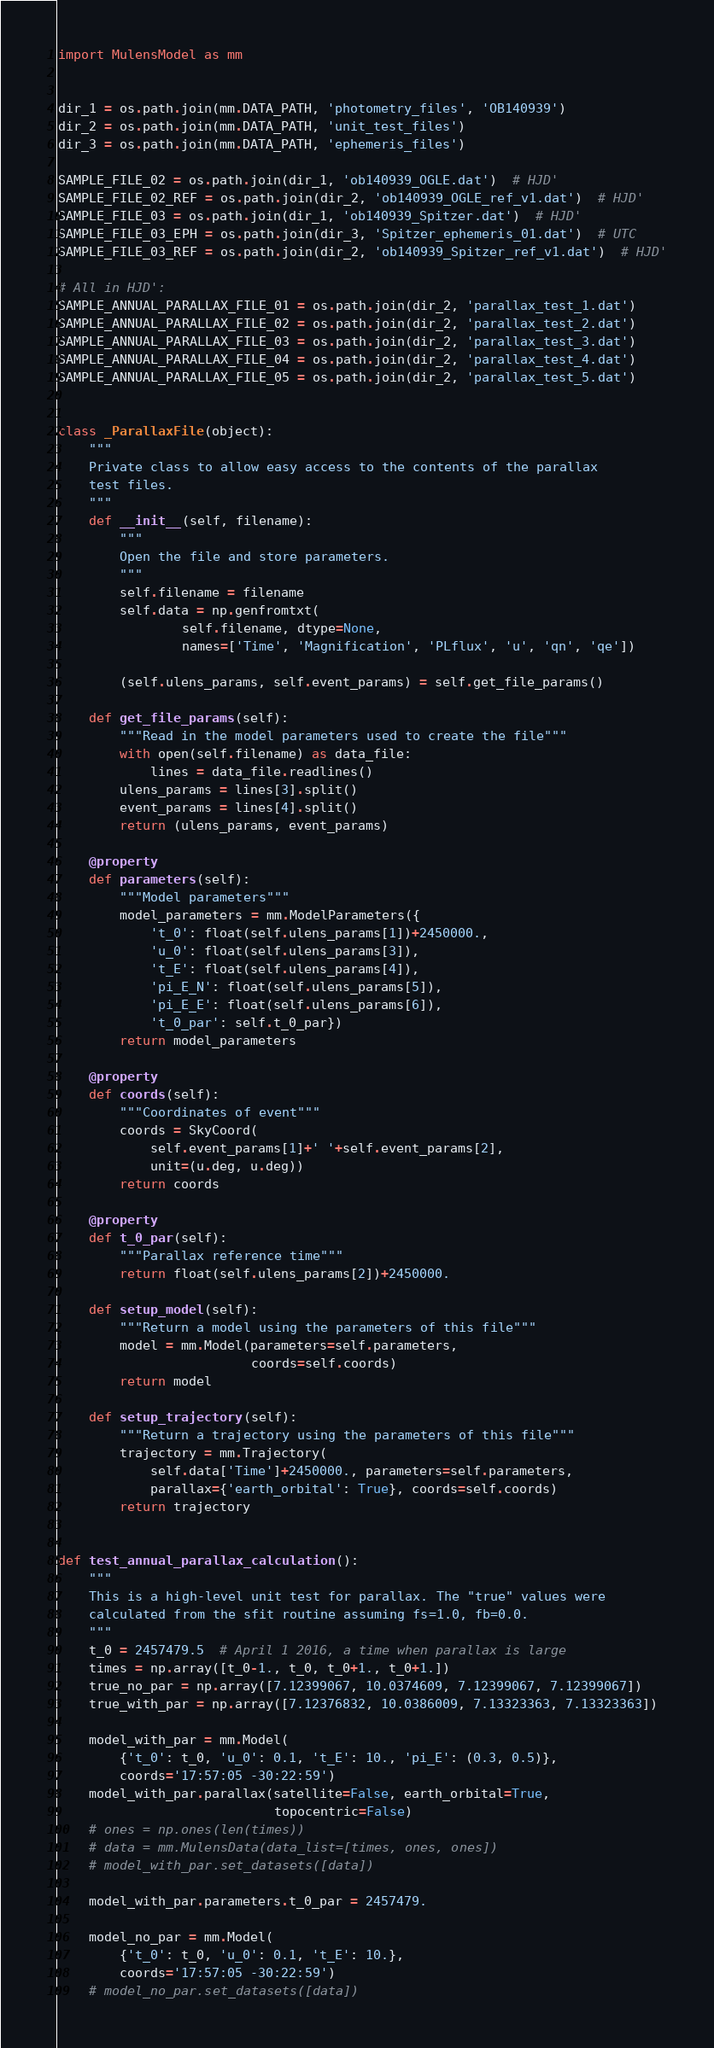Convert code to text. <code><loc_0><loc_0><loc_500><loc_500><_Python_>
import MulensModel as mm


dir_1 = os.path.join(mm.DATA_PATH, 'photometry_files', 'OB140939')
dir_2 = os.path.join(mm.DATA_PATH, 'unit_test_files')
dir_3 = os.path.join(mm.DATA_PATH, 'ephemeris_files')

SAMPLE_FILE_02 = os.path.join(dir_1, 'ob140939_OGLE.dat')  # HJD'
SAMPLE_FILE_02_REF = os.path.join(dir_2, 'ob140939_OGLE_ref_v1.dat')  # HJD'
SAMPLE_FILE_03 = os.path.join(dir_1, 'ob140939_Spitzer.dat')  # HJD'
SAMPLE_FILE_03_EPH = os.path.join(dir_3, 'Spitzer_ephemeris_01.dat')  # UTC
SAMPLE_FILE_03_REF = os.path.join(dir_2, 'ob140939_Spitzer_ref_v1.dat')  # HJD'

# All in HJD':
SAMPLE_ANNUAL_PARALLAX_FILE_01 = os.path.join(dir_2, 'parallax_test_1.dat')
SAMPLE_ANNUAL_PARALLAX_FILE_02 = os.path.join(dir_2, 'parallax_test_2.dat')
SAMPLE_ANNUAL_PARALLAX_FILE_03 = os.path.join(dir_2, 'parallax_test_3.dat')
SAMPLE_ANNUAL_PARALLAX_FILE_04 = os.path.join(dir_2, 'parallax_test_4.dat')
SAMPLE_ANNUAL_PARALLAX_FILE_05 = os.path.join(dir_2, 'parallax_test_5.dat')


class _ParallaxFile(object):
    """
    Private class to allow easy access to the contents of the parallax
    test files.
    """
    def __init__(self, filename):
        """
        Open the file and store parameters.
        """
        self.filename = filename
        self.data = np.genfromtxt(
                self.filename, dtype=None,
                names=['Time', 'Magnification', 'PLflux', 'u', 'qn', 'qe'])

        (self.ulens_params, self.event_params) = self.get_file_params()

    def get_file_params(self):
        """Read in the model parameters used to create the file"""
        with open(self.filename) as data_file:
            lines = data_file.readlines()
        ulens_params = lines[3].split()
        event_params = lines[4].split()
        return (ulens_params, event_params)

    @property
    def parameters(self):
        """Model parameters"""
        model_parameters = mm.ModelParameters({
            't_0': float(self.ulens_params[1])+2450000.,
            'u_0': float(self.ulens_params[3]),
            't_E': float(self.ulens_params[4]),
            'pi_E_N': float(self.ulens_params[5]),
            'pi_E_E': float(self.ulens_params[6]),
            't_0_par': self.t_0_par})
        return model_parameters

    @property
    def coords(self):
        """Coordinates of event"""
        coords = SkyCoord(
            self.event_params[1]+' '+self.event_params[2],
            unit=(u.deg, u.deg))
        return coords

    @property
    def t_0_par(self):
        """Parallax reference time"""
        return float(self.ulens_params[2])+2450000.

    def setup_model(self):
        """Return a model using the parameters of this file"""
        model = mm.Model(parameters=self.parameters,
                         coords=self.coords)
        return model

    def setup_trajectory(self):
        """Return a trajectory using the parameters of this file"""
        trajectory = mm.Trajectory(
            self.data['Time']+2450000., parameters=self.parameters,
            parallax={'earth_orbital': True}, coords=self.coords)
        return trajectory


def test_annual_parallax_calculation():
    """
    This is a high-level unit test for parallax. The "true" values were
    calculated from the sfit routine assuming fs=1.0, fb=0.0.
    """
    t_0 = 2457479.5  # April 1 2016, a time when parallax is large
    times = np.array([t_0-1., t_0, t_0+1., t_0+1.])
    true_no_par = np.array([7.12399067, 10.0374609, 7.12399067, 7.12399067])
    true_with_par = np.array([7.12376832, 10.0386009, 7.13323363, 7.13323363])

    model_with_par = mm.Model(
        {'t_0': t_0, 'u_0': 0.1, 't_E': 10., 'pi_E': (0.3, 0.5)},
        coords='17:57:05 -30:22:59')
    model_with_par.parallax(satellite=False, earth_orbital=True,
                            topocentric=False)
    # ones = np.ones(len(times))
    # data = mm.MulensData(data_list=[times, ones, ones])
    # model_with_par.set_datasets([data])

    model_with_par.parameters.t_0_par = 2457479.

    model_no_par = mm.Model(
        {'t_0': t_0, 'u_0': 0.1, 't_E': 10.},
        coords='17:57:05 -30:22:59')
    # model_no_par.set_datasets([data])</code> 